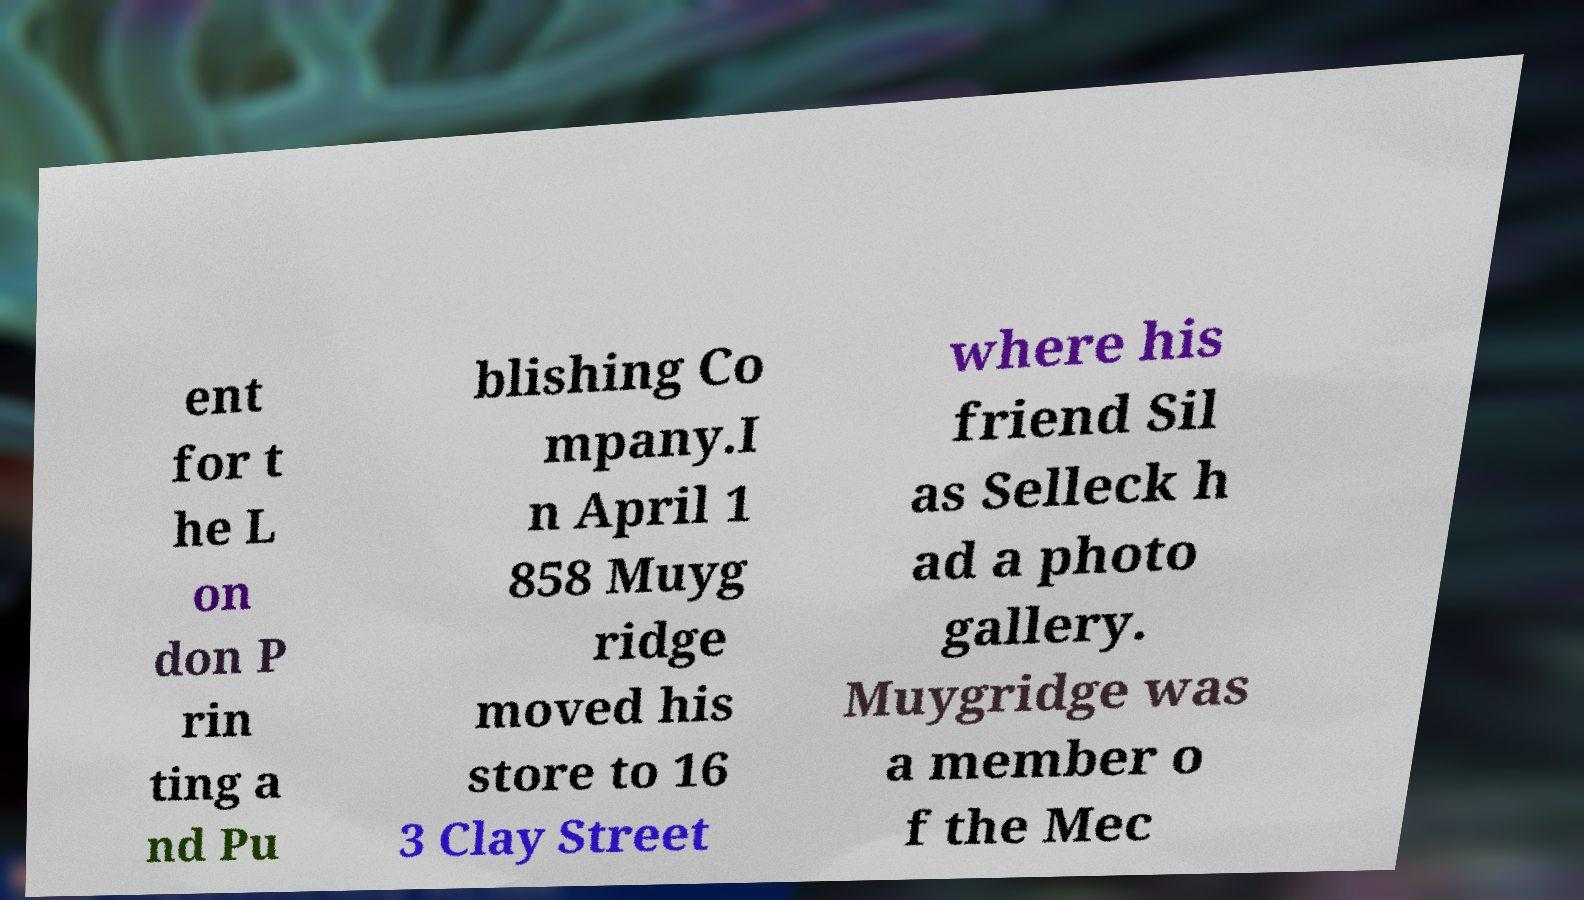What messages or text are displayed in this image? I need them in a readable, typed format. ent for t he L on don P rin ting a nd Pu blishing Co mpany.I n April 1 858 Muyg ridge moved his store to 16 3 Clay Street where his friend Sil as Selleck h ad a photo gallery. Muygridge was a member o f the Mec 